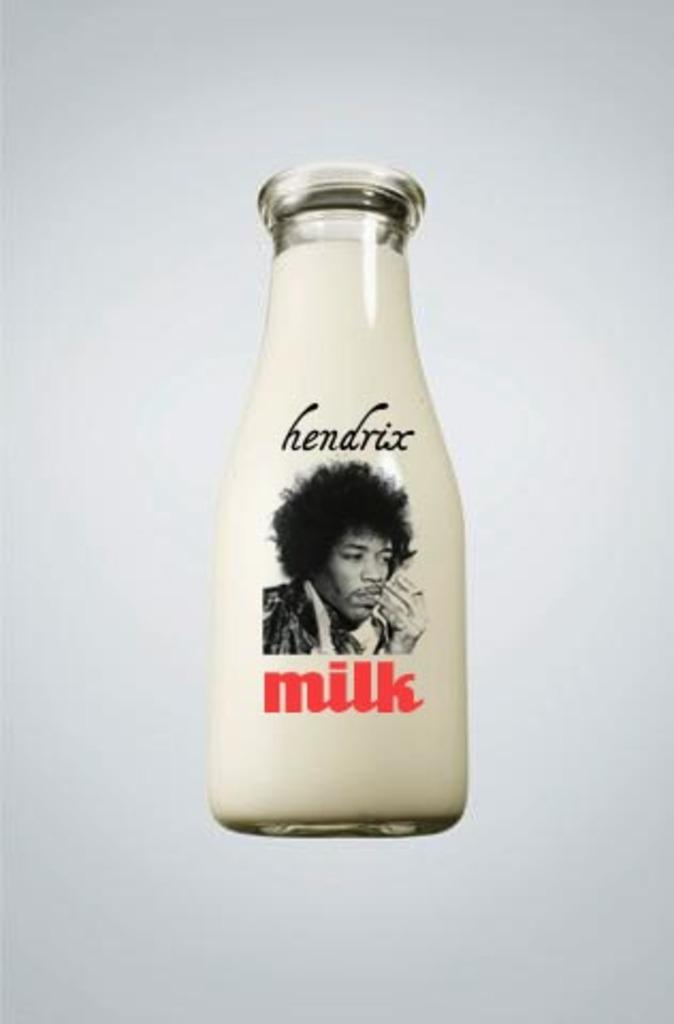What object is present in the image that contains a liquid? There is a milk bottle in the picture. What is depicted on the milk bottle? The milk bottle has an image of a person on it. Are there any words or letters on the milk bottle? Yes, there is text on the milk bottle. What color is the background of the image? The background of the image is white. Can you see a crook or a stamp in the image? No, there is no crook or stamp present in the image. 